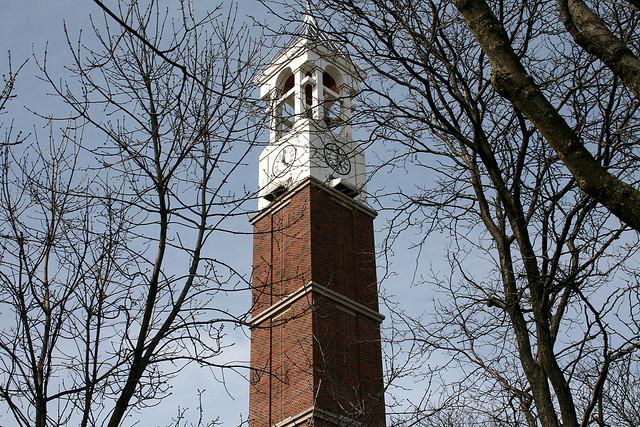Is part of this tower made of wood?
Be succinct. No. What information does this tower give?
Keep it brief. Time. Was this picture taken in July?
Quick response, please. No. 